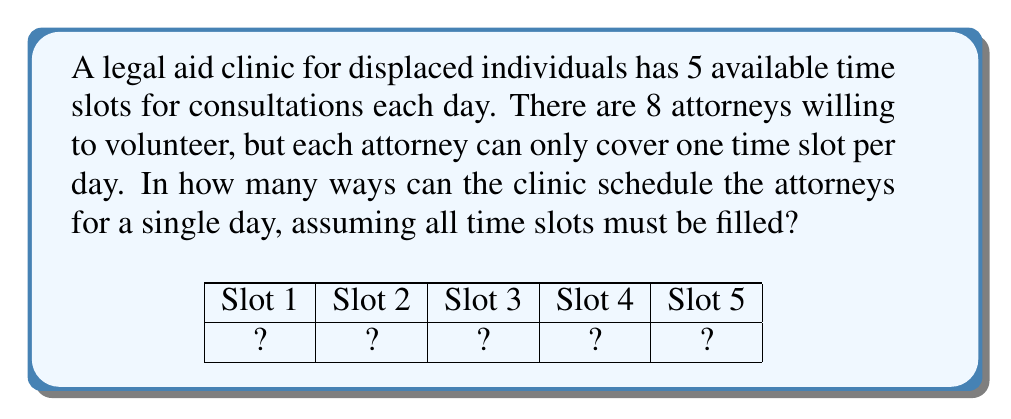Help me with this question. Let's approach this step-by-step:

1) This is a permutation problem. We are selecting 5 attorneys out of 8 and arranging them in a specific order (since the time slots matter).

2) The formula for permutations is:

   $$P(n,r) = \frac{n!}{(n-r)!}$$

   Where $n$ is the total number of items to choose from, and $r$ is the number of items being chosen.

3) In this case, $n = 8$ (total number of attorneys) and $r = 5$ (number of time slots to fill).

4) Plugging these values into our formula:

   $$P(8,5) = \frac{8!}{(8-5)!} = \frac{8!}{3!}$$

5) Let's calculate this:
   
   $$\frac{8!}{3!} = \frac{8 \times 7 \times 6 \times 5 \times 4 \times 3!}{3!}$$

6) The $3!$ cancels out in the numerator and denominator:

   $$8 \times 7 \times 6 \times 5 \times 4 = 6720$$

Therefore, there are 6720 possible ways to schedule the attorneys for a single day.
Answer: 6720 